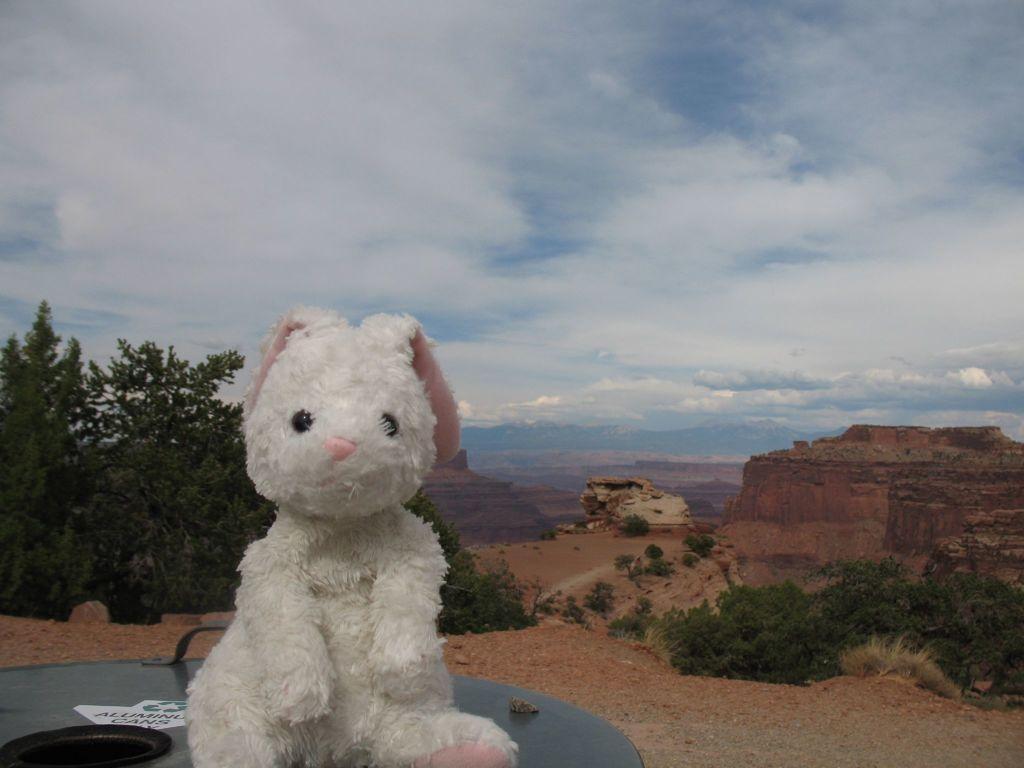How would you summarize this image in a sentence or two? In this picture, we see the stuffed toy in white and pink color is placed on the table. We see a black color object, poster and a stone are placed on the table. At the bottom, we see the stones. On the right side, we see the trees and the rocks. On the left side, we see the trees and the rocks. There are trees in the background. At the top, we see the sky and the clouds. 